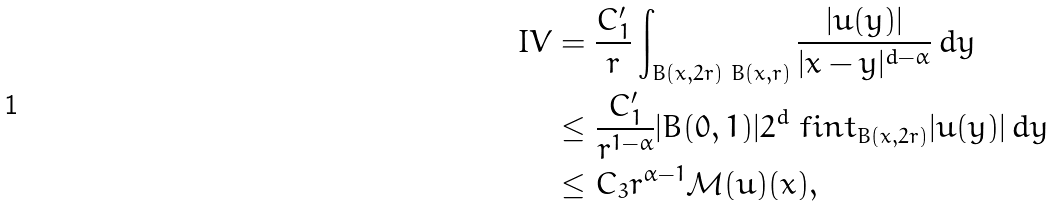<formula> <loc_0><loc_0><loc_500><loc_500>I V & = \frac { C _ { 1 } ^ { \prime } } { r } \int _ { B ( x , 2 r ) \ B ( x , r ) } \frac { | u ( y ) | } { | x - y | ^ { d - \alpha } } \, d y \\ & \leq \frac { C _ { 1 } ^ { \prime } } { r ^ { 1 - \alpha } } | B ( 0 , 1 ) | 2 ^ { d } \ f i n t _ { B ( x , 2 r ) } | u ( y ) | \, d y \\ & \leq C _ { 3 } r ^ { \alpha - 1 } \mathcal { M } ( u ) ( x ) ,</formula> 